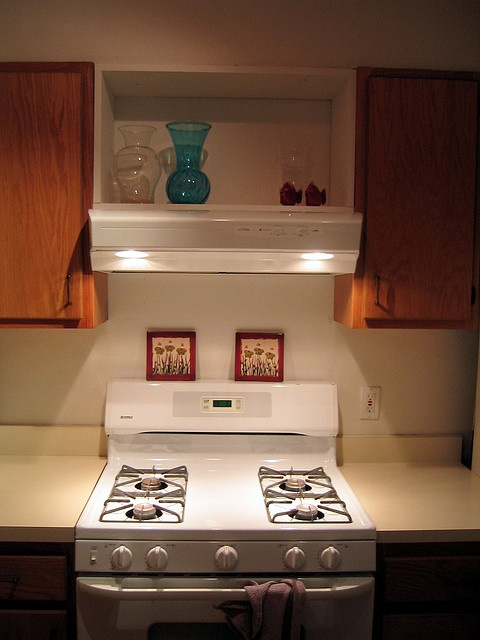Describe the objects in this image and their specific colors. I can see oven in maroon, black, white, and tan tones, vase in maroon, black, darkgreen, and teal tones, vase in maroon, brown, and gray tones, and vase in maroon, black, and brown tones in this image. 